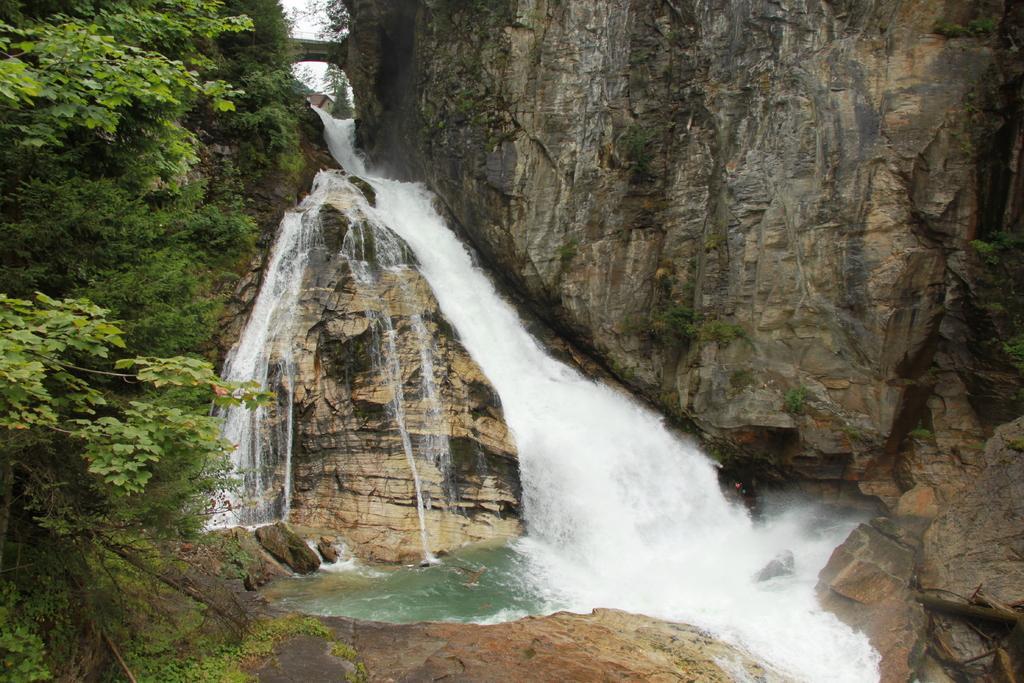Can you describe this image briefly? In this image in the front on the left side there are trees. In the center there is a waterfall and in the background there are rocks. 